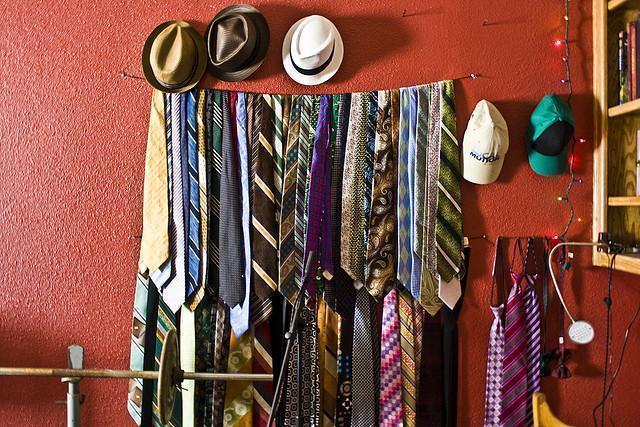Who does this room belong to?
Select the accurate answer and provide justification: `Answer: choice
Rationale: srationale.`
Options: Man, girl, woman, baby. Answer: man.
Rationale: There are ties which when usually wear. 